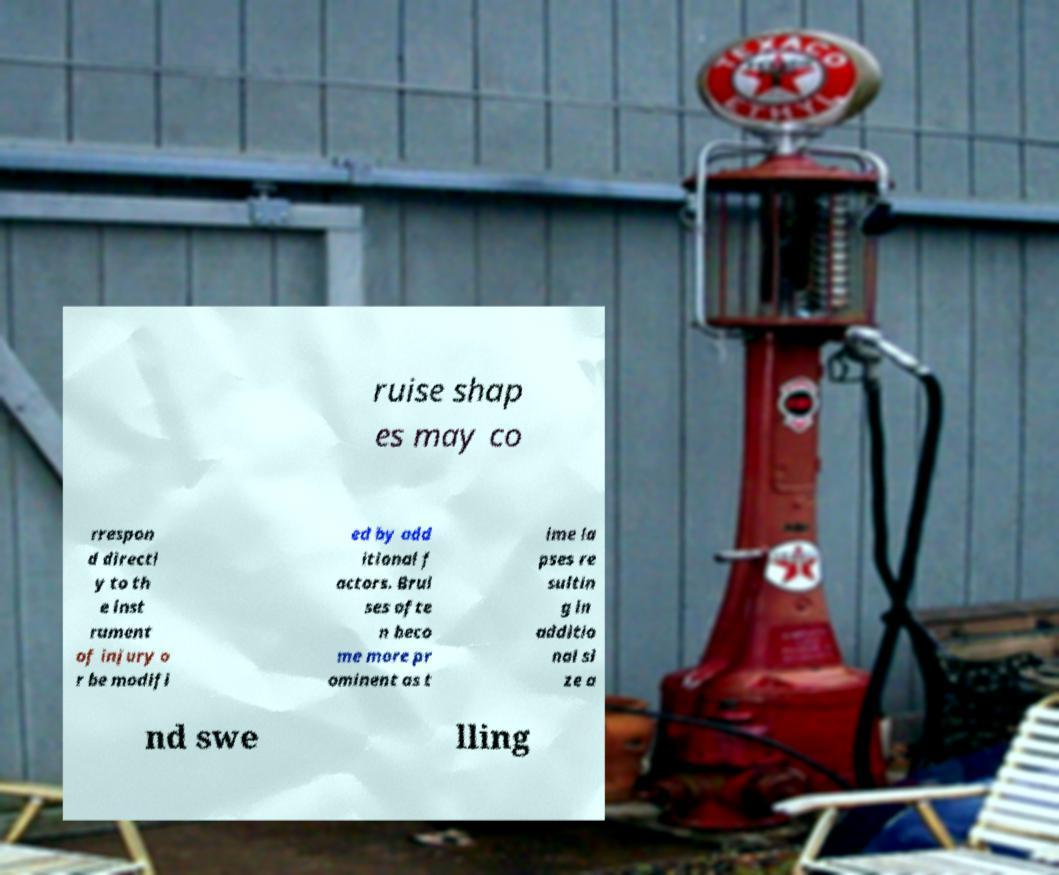Can you read and provide the text displayed in the image?This photo seems to have some interesting text. Can you extract and type it out for me? ruise shap es may co rrespon d directl y to th e inst rument of injury o r be modifi ed by add itional f actors. Brui ses ofte n beco me more pr ominent as t ime la pses re sultin g in additio nal si ze a nd swe lling 